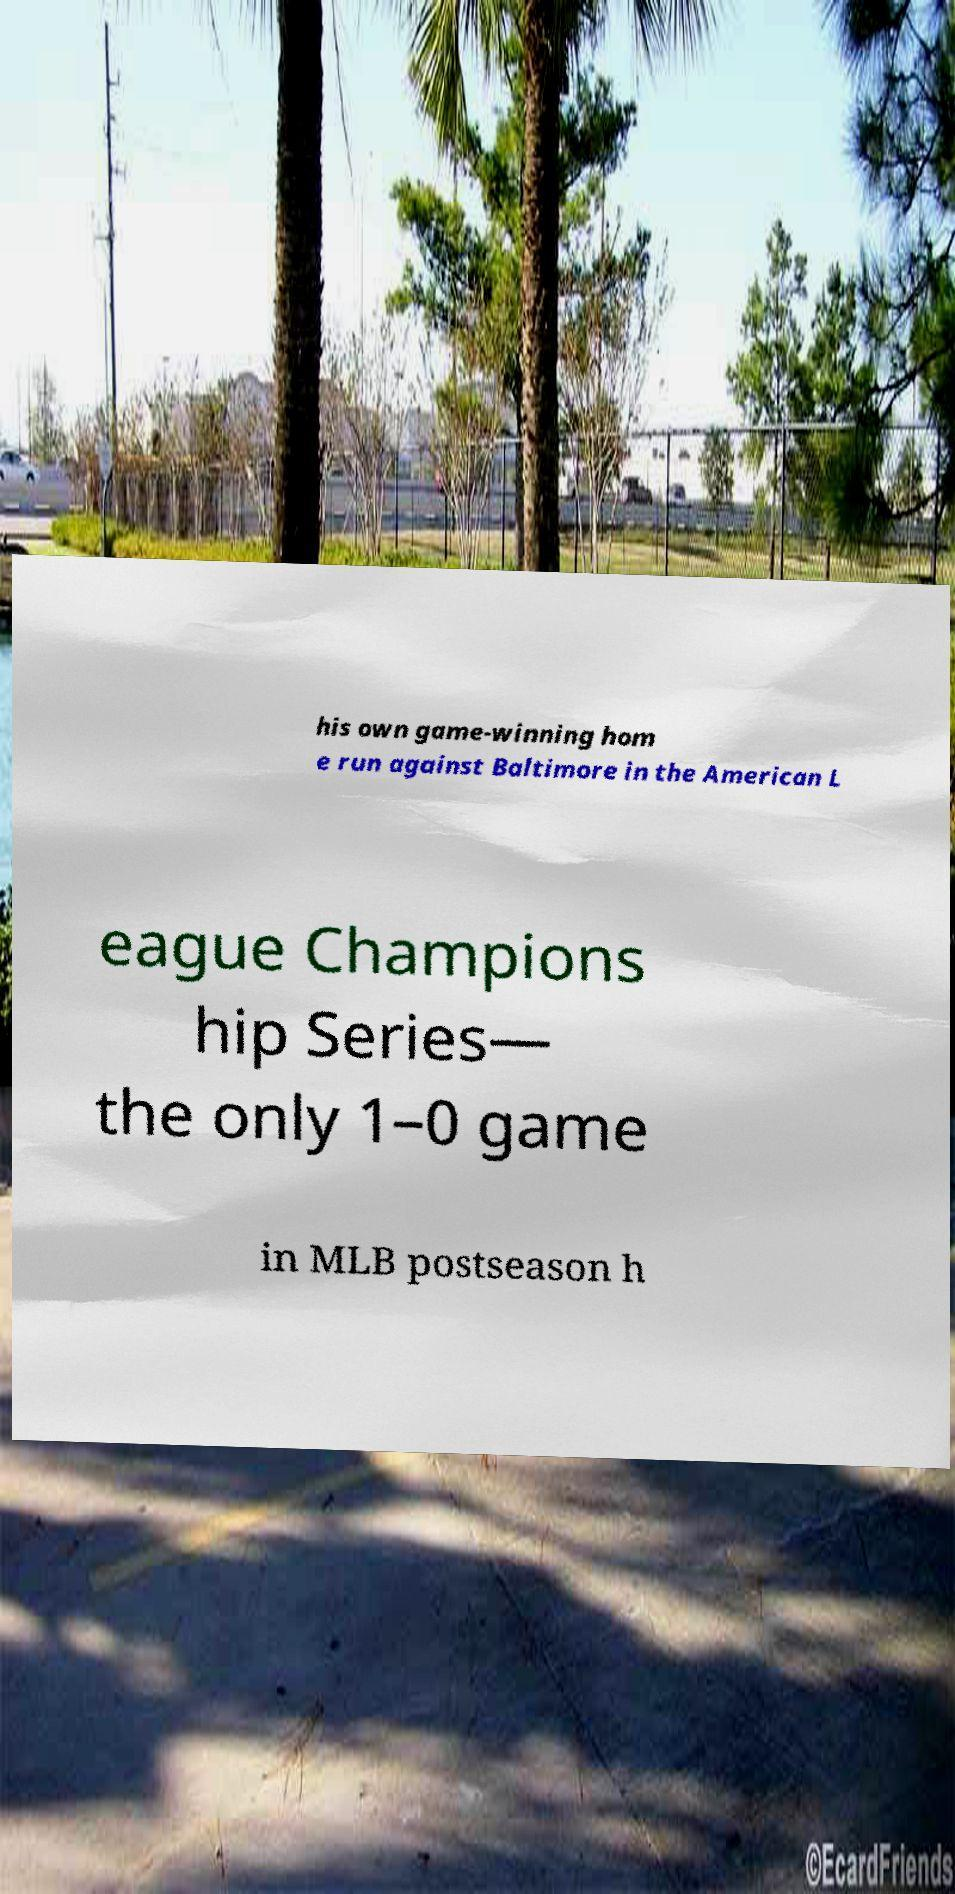Can you read and provide the text displayed in the image?This photo seems to have some interesting text. Can you extract and type it out for me? his own game-winning hom e run against Baltimore in the American L eague Champions hip Series— the only 1–0 game in MLB postseason h 